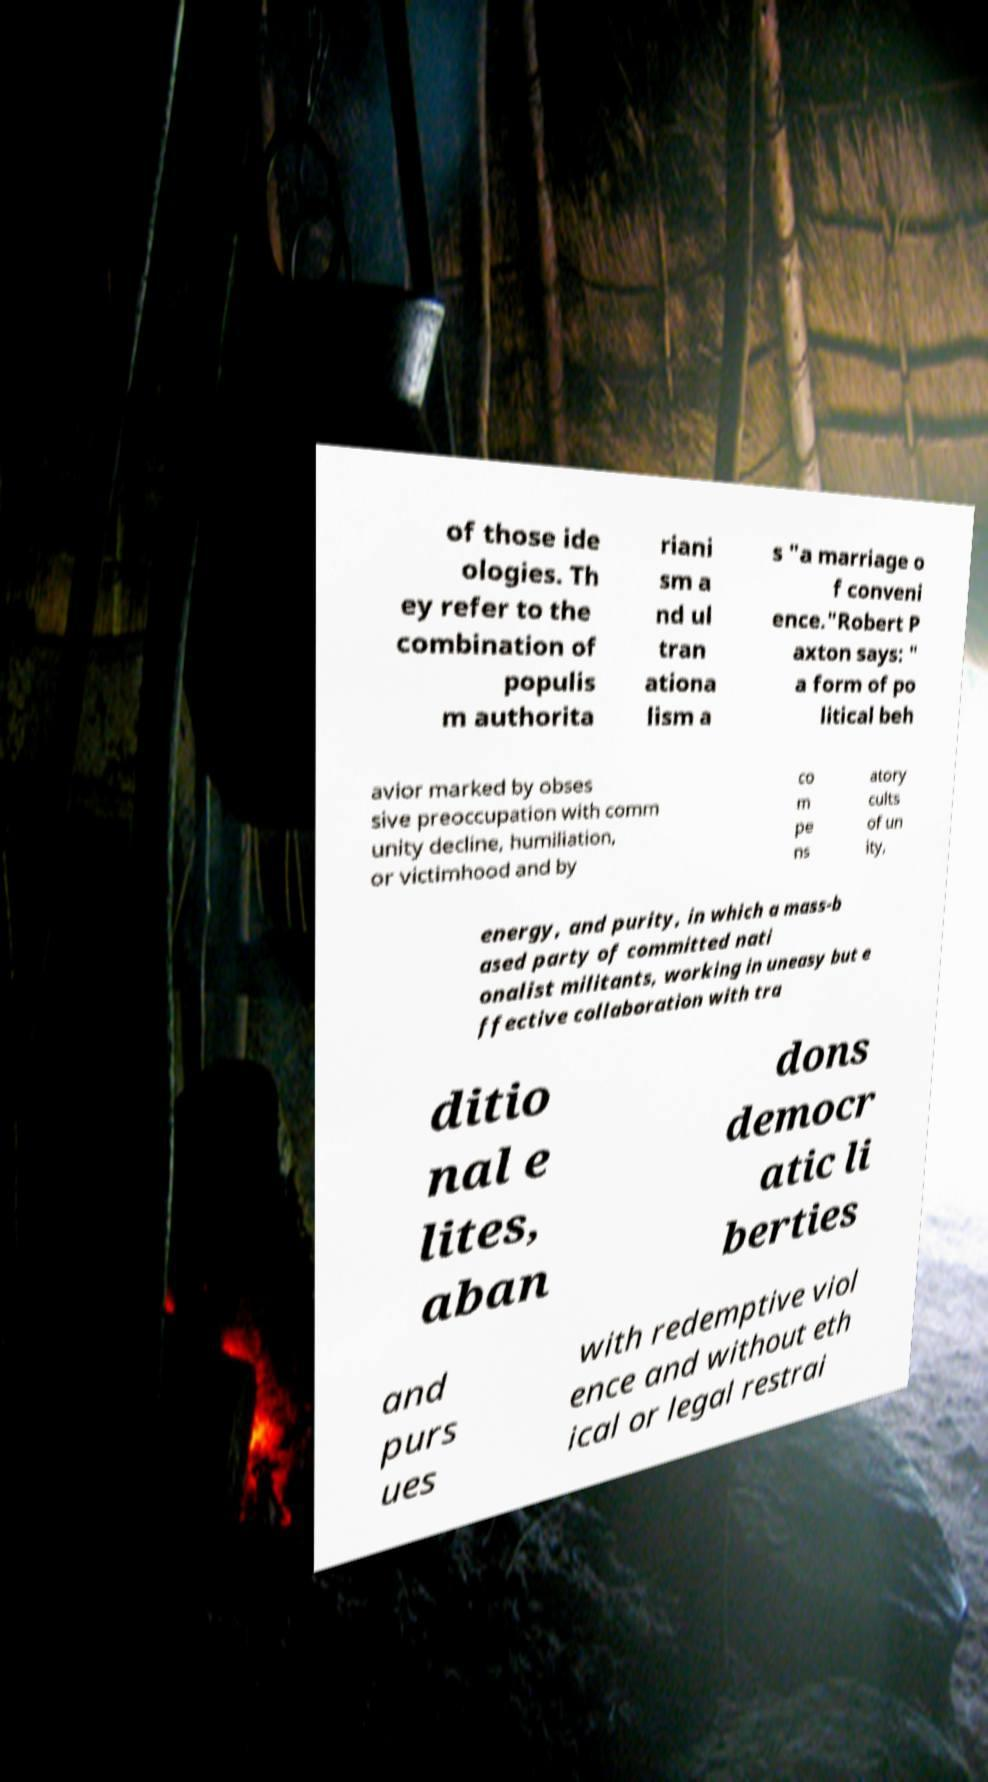There's text embedded in this image that I need extracted. Can you transcribe it verbatim? of those ide ologies. Th ey refer to the combination of populis m authorita riani sm a nd ul tran ationa lism a s "a marriage o f conveni ence."Robert P axton says: " a form of po litical beh avior marked by obses sive preoccupation with comm unity decline, humiliation, or victimhood and by co m pe ns atory cults of un ity, energy, and purity, in which a mass-b ased party of committed nati onalist militants, working in uneasy but e ffective collaboration with tra ditio nal e lites, aban dons democr atic li berties and purs ues with redemptive viol ence and without eth ical or legal restrai 